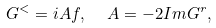<formula> <loc_0><loc_0><loc_500><loc_500>G ^ { < } = i A f , \ \ A = - 2 I m G ^ { r } ,</formula> 